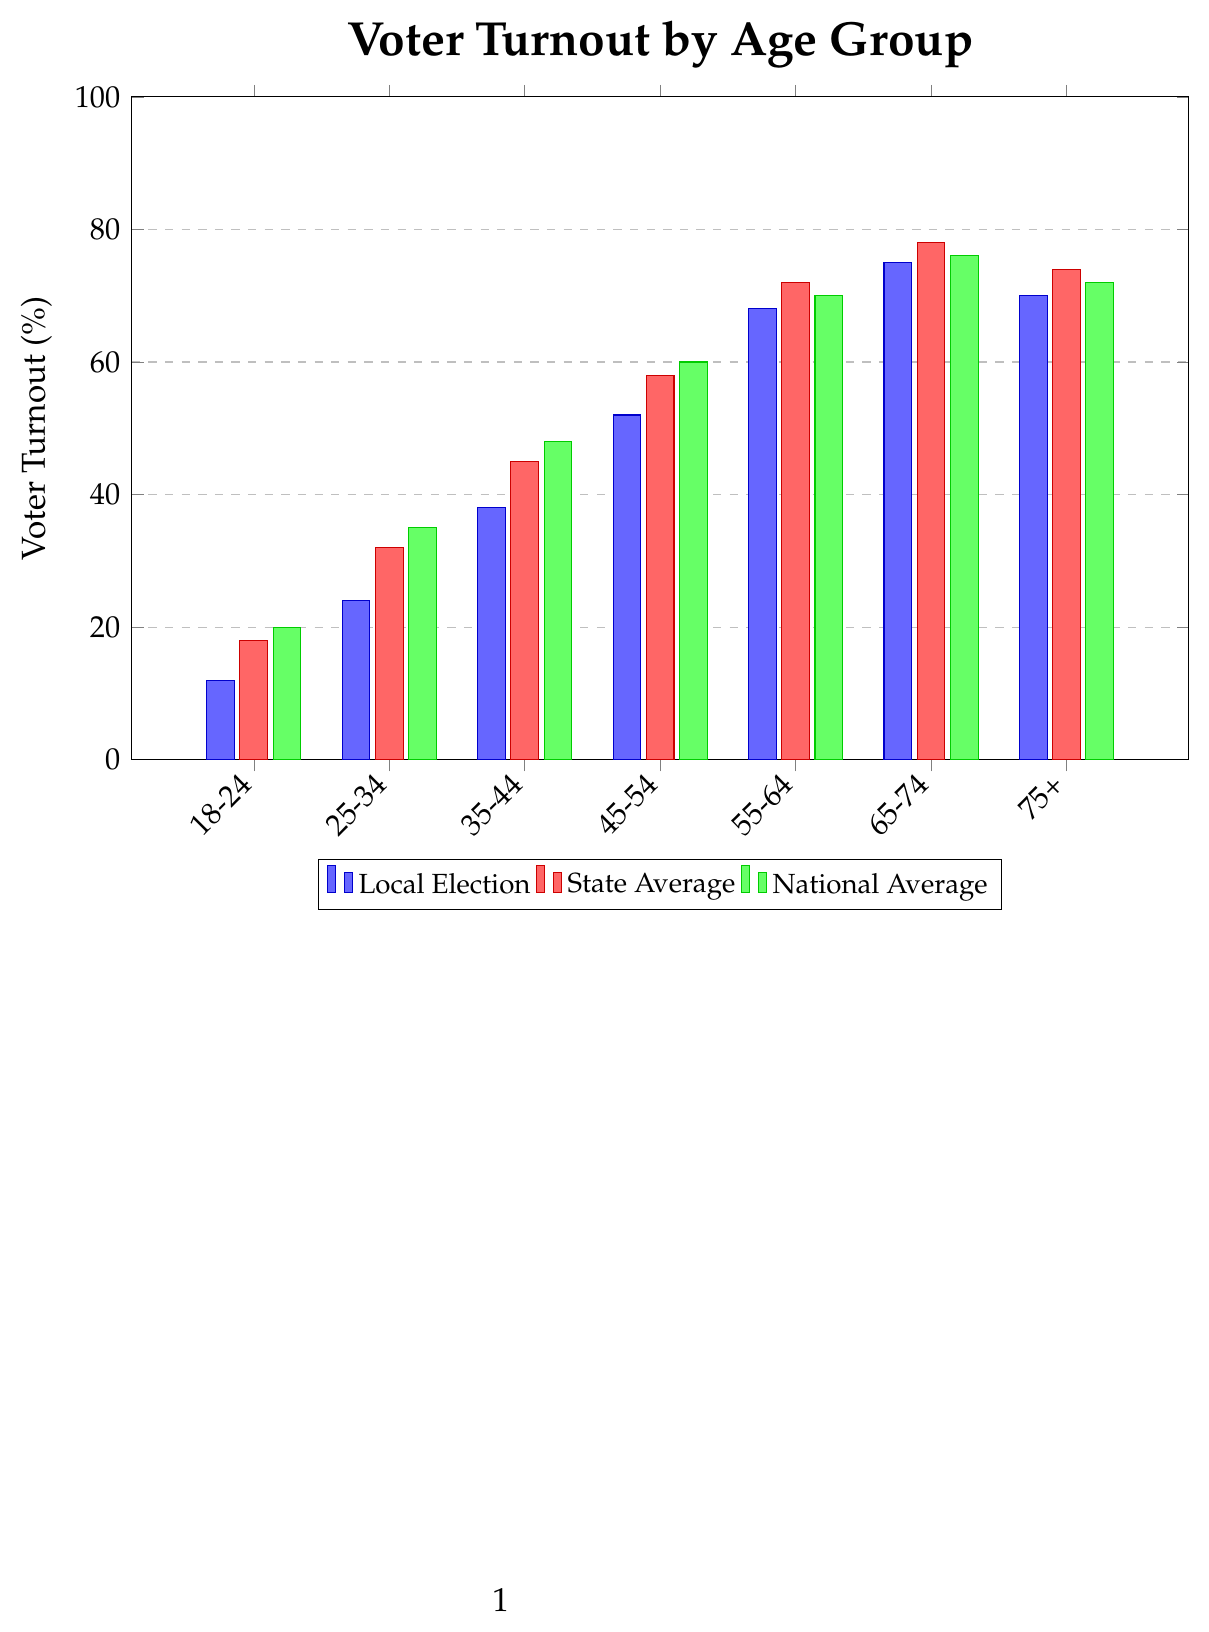What is the voter turnout percentage for the age group 35-44 in local elections? Look for the bar corresponding to the 35-44 age group for local elections, which is denoted by the blue bar. The label on the y-axis shows 38%.
Answer: 38% How does the turnout of the 18-24 age group in local elections compare to the state average for the same age group? Compare the blue bar (local elections, 12%) to the red bar (state average, 18%) for the 18-24 age group. The local election turnout is 6% lower than the state average.
Answer: 6% lower Which age group has the highest voter turnout in local elections and what is the turnout percentage? Identify the tallest blue bar in the plot, which corresponds to the 65-74 age group, with 75% voter turnout.
Answer: 65-74, 75% What is the difference in voter turnout between the 55-64 and 75+ age groups in national averages? Compare the green bars for 55-64 (70%) and 75+ (72%). The difference is 2% (72% - 70%).
Answer: 2% For which age groups is the local election turnout less than the state average but greater than the national average? Check the relative positions of the blue, red, and green bars. The age group 65-74 has a local turnout (75%) greater than national (76%) but less than state (78%).
Answer: 65-74 What is the average voter turnout in local elections for all age groups combined? Sum the local election turnout percentages and divide by the number of age groups. (12 + 24 + 38 + 52 + 68 + 75 + 70) / 7 = 339 / 7 ≈ 48.43%
Answer: 48.43% Which age group has the smallest gap between local election turnout and national average, and what is this gap? Compare the absolute differences for all pairs of blue and green bars. The 55-64 age group has a gap of 2% (68% local and 70% national).
Answer: 55-64, 2% What is the combined voter turnout for the 25-34 age group in state and national averages? Add the voter turnouts for state and national averages for the 25-34 age group: 32% (state) + 35% (national) = 67%.
Answer: 67% Which age group shows the greatest improvement in voter turnout from local elections to national elections? Calculate the differences between local and national averages for each group. The 18-24 group shows the greatest difference: 20% (national) - 12% (local) = 8%.
Answer: 18-24, 8% 